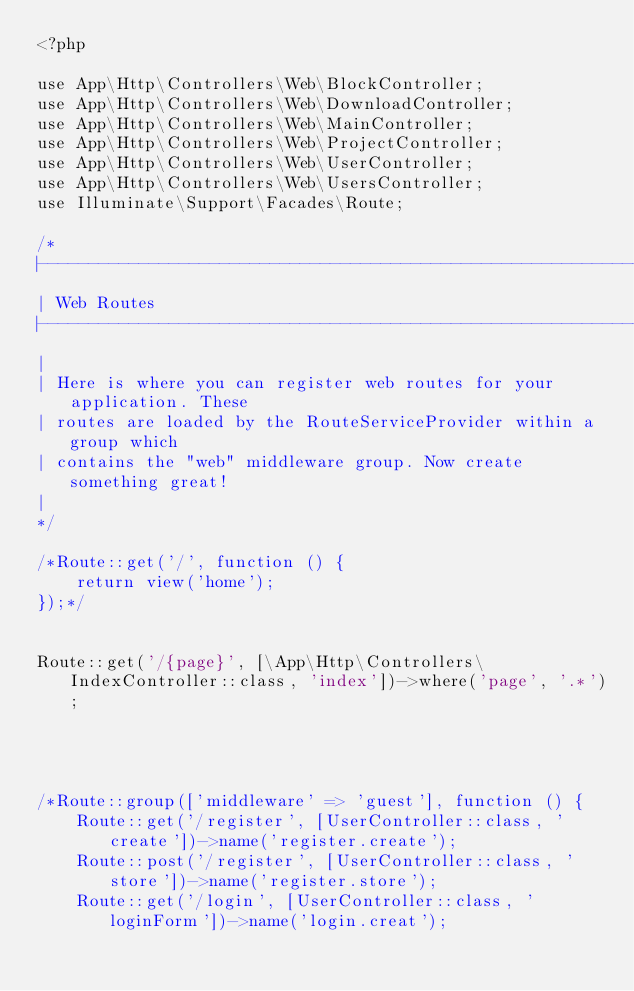Convert code to text. <code><loc_0><loc_0><loc_500><loc_500><_PHP_><?php

use App\Http\Controllers\Web\BlockController;
use App\Http\Controllers\Web\DownloadController;
use App\Http\Controllers\Web\MainController;
use App\Http\Controllers\Web\ProjectController;
use App\Http\Controllers\Web\UserController;
use App\Http\Controllers\Web\UsersController;
use Illuminate\Support\Facades\Route;

/*
|--------------------------------------------------------------------------
| Web Routes
|--------------------------------------------------------------------------
|
| Here is where you can register web routes for your application. These
| routes are loaded by the RouteServiceProvider within a group which
| contains the "web" middleware group. Now create something great!
|
*/

/*Route::get('/', function () {
    return view('home');
});*/


Route::get('/{page}', [\App\Http\Controllers\IndexController::class, 'index'])->where('page', '.*');




/*Route::group(['middleware' => 'guest'], function () {
    Route::get('/register', [UserController::class, 'create'])->name('register.create');
    Route::post('/register', [UserController::class, 'store'])->name('register.store');
    Route::get('/login', [UserController::class, 'loginForm'])->name('login.creat');</code> 